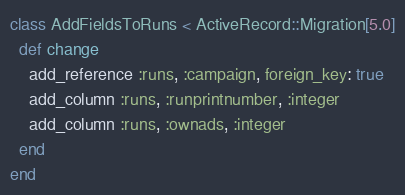<code> <loc_0><loc_0><loc_500><loc_500><_Ruby_>class AddFieldsToRuns < ActiveRecord::Migration[5.0]
  def change
    add_reference :runs, :campaign, foreign_key: true
    add_column :runs, :runprintnumber, :integer
    add_column :runs, :ownads, :integer
  end
end
</code> 